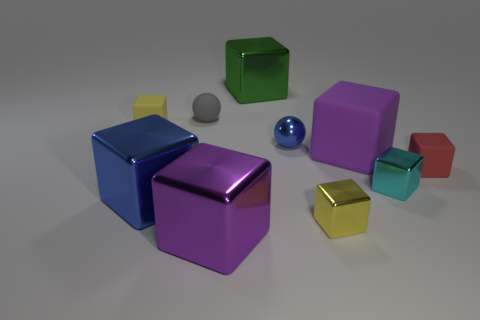There is a yellow metallic object right of the gray object; does it have the same shape as the small metal object behind the big purple matte cube?
Give a very brief answer. No. Are there any brown metallic objects that have the same size as the gray sphere?
Give a very brief answer. No. What is the yellow block that is to the left of the small gray object made of?
Provide a short and direct response. Rubber. Is the yellow object behind the tiny yellow metal cube made of the same material as the red cube?
Provide a succinct answer. Yes. Are any cyan shiny things visible?
Provide a succinct answer. Yes. What color is the other big object that is the same material as the red object?
Provide a short and direct response. Purple. What is the color of the ball that is right of the big cube behind the tiny yellow block that is to the left of the large blue object?
Make the answer very short. Blue. There is a blue metallic cube; does it have the same size as the block behind the yellow rubber block?
Your response must be concise. Yes. What number of objects are tiny matte cubes that are to the left of the big purple metallic block or purple things behind the small yellow metal cube?
Your answer should be compact. 2. What is the shape of the purple shiny object that is the same size as the green object?
Offer a terse response. Cube. 